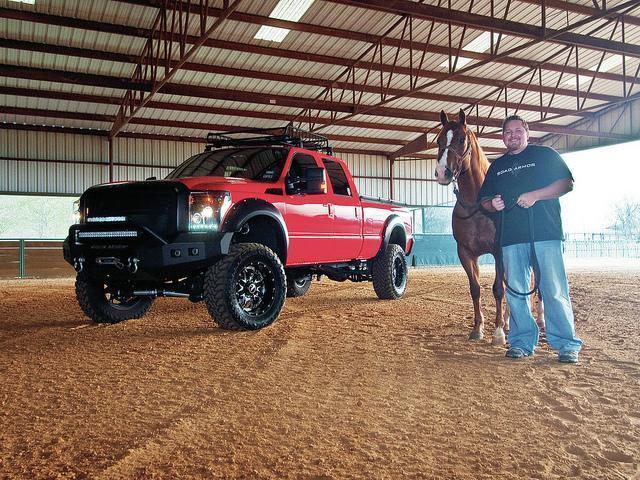Is the statement "The horse is at the right side of the truck." accurate regarding the image?
Answer yes or no. Yes. 